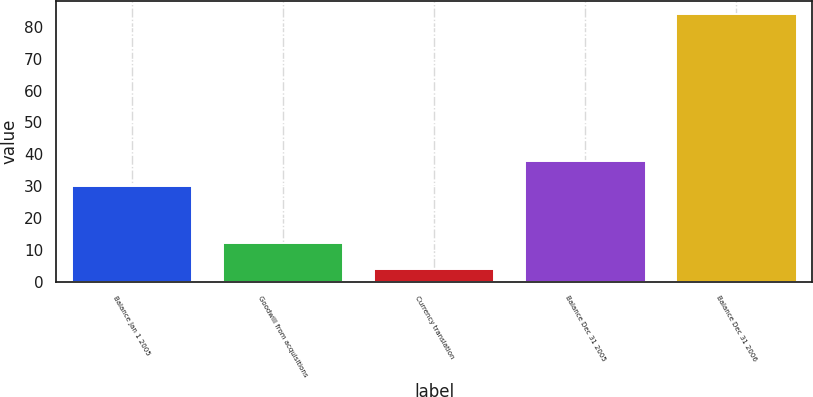Convert chart to OTSL. <chart><loc_0><loc_0><loc_500><loc_500><bar_chart><fcel>Balance Jan 1 2005<fcel>Goodwill from acquisitions<fcel>Currency translation<fcel>Balance Dec 31 2005<fcel>Balance Dec 31 2006<nl><fcel>30<fcel>12<fcel>4<fcel>38<fcel>84<nl></chart> 